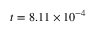<formula> <loc_0><loc_0><loc_500><loc_500>t = 8 . 1 1 \times 1 0 ^ { - 4 }</formula> 